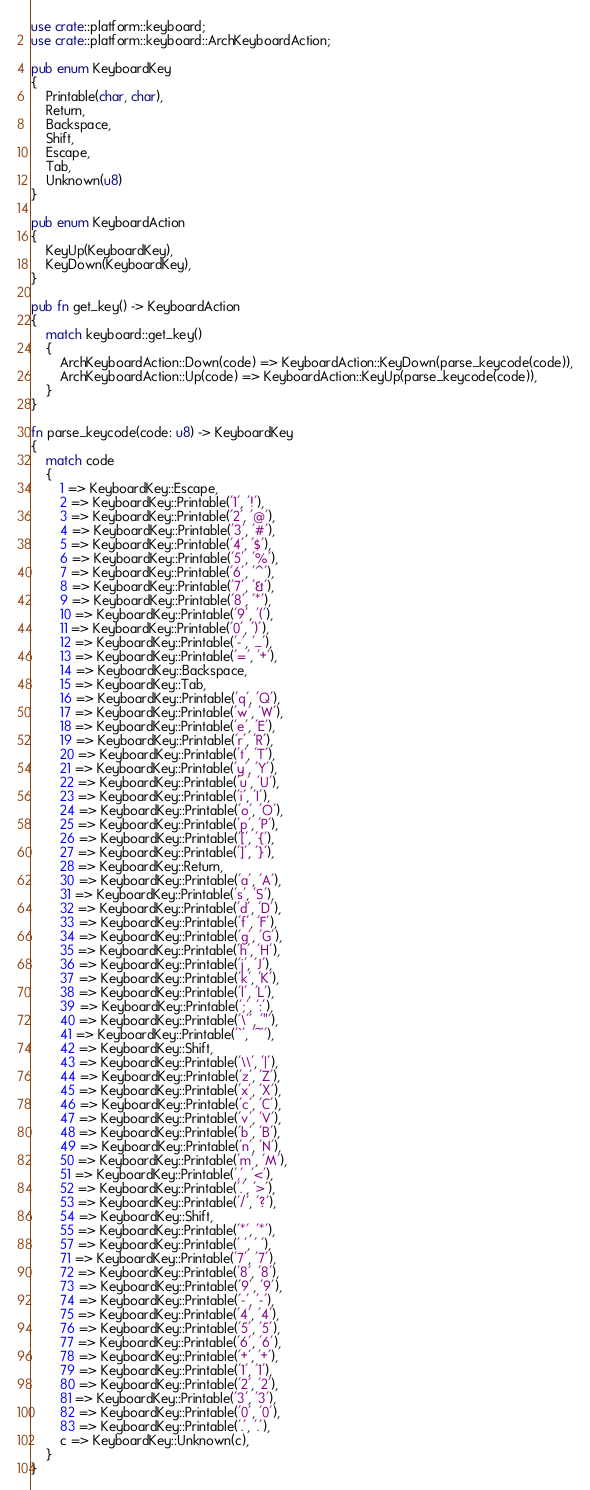Convert code to text. <code><loc_0><loc_0><loc_500><loc_500><_Rust_>use crate::platform::keyboard;
use crate::platform::keyboard::ArchKeyboardAction;

pub enum KeyboardKey
{
	Printable(char, char),
	Return,
	Backspace,
	Shift,
	Escape,
	Tab,
	Unknown(u8)
}

pub enum KeyboardAction
{
	KeyUp(KeyboardKey),
	KeyDown(KeyboardKey),
}

pub fn get_key() -> KeyboardAction
{
	match keyboard::get_key()
	{
		ArchKeyboardAction::Down(code) => KeyboardAction::KeyDown(parse_keycode(code)),
		ArchKeyboardAction::Up(code) => KeyboardAction::KeyUp(parse_keycode(code)),
	}
}

fn parse_keycode(code: u8) -> KeyboardKey
{
	match code
	{
		1 => KeyboardKey::Escape,
		2 => KeyboardKey::Printable('1', '!'),
		3 => KeyboardKey::Printable('2', '@'),
		4 => KeyboardKey::Printable('3', '#'),
		5 => KeyboardKey::Printable('4', '$'),
		6 => KeyboardKey::Printable('5', '%'),
		7 => KeyboardKey::Printable('6', '^'),
		8 => KeyboardKey::Printable('7', '&'),
		9 => KeyboardKey::Printable('8', '*'),
		10 => KeyboardKey::Printable('9', '('),
		11 => KeyboardKey::Printable('0', ')'),
		12 => KeyboardKey::Printable('-', '_'),
		13 => KeyboardKey::Printable('=', '+'),
		14 => KeyboardKey::Backspace,
		15 => KeyboardKey::Tab,
		16 => KeyboardKey::Printable('q', 'Q'),
		17 => KeyboardKey::Printable('w', 'W'),
		18 => KeyboardKey::Printable('e', 'E'),
		19 => KeyboardKey::Printable('r', 'R'),
		20 => KeyboardKey::Printable('t', 'T'),
		21 => KeyboardKey::Printable('y', 'Y'),
		22 => KeyboardKey::Printable('u', 'U'),
		23 => KeyboardKey::Printable('i', 'I'),
		24 => KeyboardKey::Printable('o', 'O'),
		25 => KeyboardKey::Printable('p', 'P'),
		26 => KeyboardKey::Printable('[', '{'),
		27 => KeyboardKey::Printable(']', '}'),
		28 => KeyboardKey::Return,
		30 => KeyboardKey::Printable('a', 'A'),
		31 => KeyboardKey::Printable('s', 'S'),
		32 => KeyboardKey::Printable('d', 'D'),
		33 => KeyboardKey::Printable('f', 'F'),
		34 => KeyboardKey::Printable('g', 'G'),
		35 => KeyboardKey::Printable('h', 'H'),
		36 => KeyboardKey::Printable('j', 'J'),
		37 => KeyboardKey::Printable('k', 'K'),
		38 => KeyboardKey::Printable('l', 'L'),
		39 => KeyboardKey::Printable(';', ':'),
		40 => KeyboardKey::Printable('\'', '"'),
		41 => KeyboardKey::Printable('`', '~'),
		42 => KeyboardKey::Shift,
		43 => KeyboardKey::Printable('\\', '|'),
		44 => KeyboardKey::Printable('z', 'Z'),
		45 => KeyboardKey::Printable('x', 'X'),
		46 => KeyboardKey::Printable('c', 'C'),
		47 => KeyboardKey::Printable('v', 'V'),
		48 => KeyboardKey::Printable('b', 'B'),
		49 => KeyboardKey::Printable('n', 'N'),
		50 => KeyboardKey::Printable('m', 'M'),
		51 => KeyboardKey::Printable(',', '<'),
		52 => KeyboardKey::Printable('.', '>'),
		53 => KeyboardKey::Printable('/', '?'),
		54 => KeyboardKey::Shift,
		55 => KeyboardKey::Printable('*', '*'),
		57 => KeyboardKey::Printable(' ', ' '),
		71 => KeyboardKey::Printable('7', '7'),
		72 => KeyboardKey::Printable('8', '8'),
		73 => KeyboardKey::Printable('9', '9'),
		74 => KeyboardKey::Printable('-', '-'),
		75 => KeyboardKey::Printable('4', '4'),
		76 => KeyboardKey::Printable('5', '5'),
		77 => KeyboardKey::Printable('6', '6'),
		78 => KeyboardKey::Printable('+', '+'),
		79 => KeyboardKey::Printable('1', '1'),
		80 => KeyboardKey::Printable('2', '2'),
		81 => KeyboardKey::Printable('3', '3'),
		82 => KeyboardKey::Printable('0', '0'),
		83 => KeyboardKey::Printable('.', '.'),
		c => KeyboardKey::Unknown(c),
	}
}
</code> 